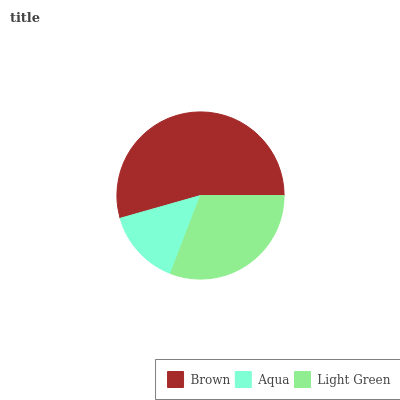Is Aqua the minimum?
Answer yes or no. Yes. Is Brown the maximum?
Answer yes or no. Yes. Is Light Green the minimum?
Answer yes or no. No. Is Light Green the maximum?
Answer yes or no. No. Is Light Green greater than Aqua?
Answer yes or no. Yes. Is Aqua less than Light Green?
Answer yes or no. Yes. Is Aqua greater than Light Green?
Answer yes or no. No. Is Light Green less than Aqua?
Answer yes or no. No. Is Light Green the high median?
Answer yes or no. Yes. Is Light Green the low median?
Answer yes or no. Yes. Is Aqua the high median?
Answer yes or no. No. Is Aqua the low median?
Answer yes or no. No. 